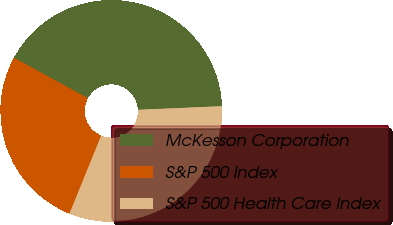Convert chart. <chart><loc_0><loc_0><loc_500><loc_500><pie_chart><fcel>McKesson Corporation<fcel>S&P 500 Index<fcel>S&P 500 Health Care Index<nl><fcel>41.36%<fcel>26.81%<fcel>31.83%<nl></chart> 